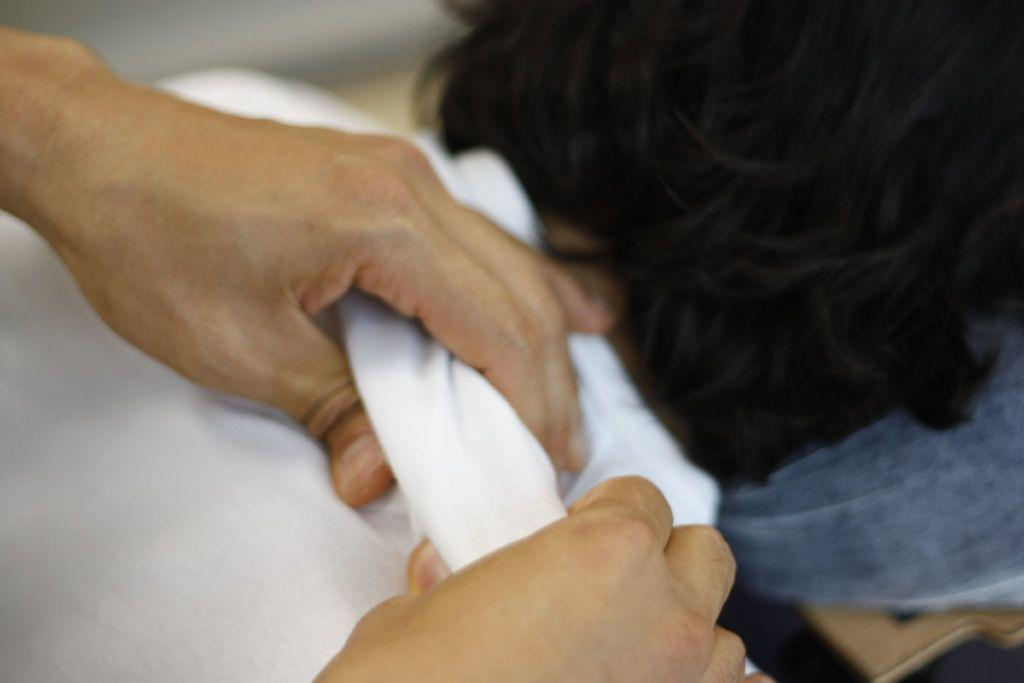What is the position of the person in the image? There is a person lying on a surface in the image. What can be seen being held by hands in the image? There are hands holding a cloth in the image. How does the person in the image say good-bye to the person holding the cloth? There is no indication in the image that the person is saying good-bye or interacting with the person holding the cloth. 